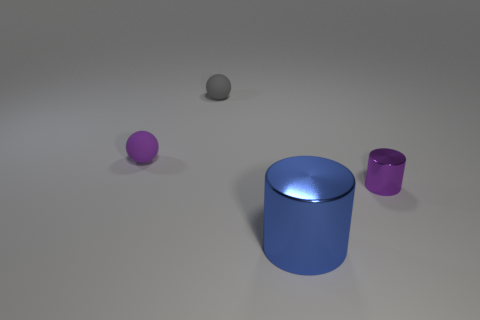Add 2 blue things. How many objects exist? 6 Add 3 tiny things. How many tiny things are left? 6 Add 2 green rubber cubes. How many green rubber cubes exist? 2 Subtract 0 green balls. How many objects are left? 4 Subtract all brown matte blocks. Subtract all blue things. How many objects are left? 3 